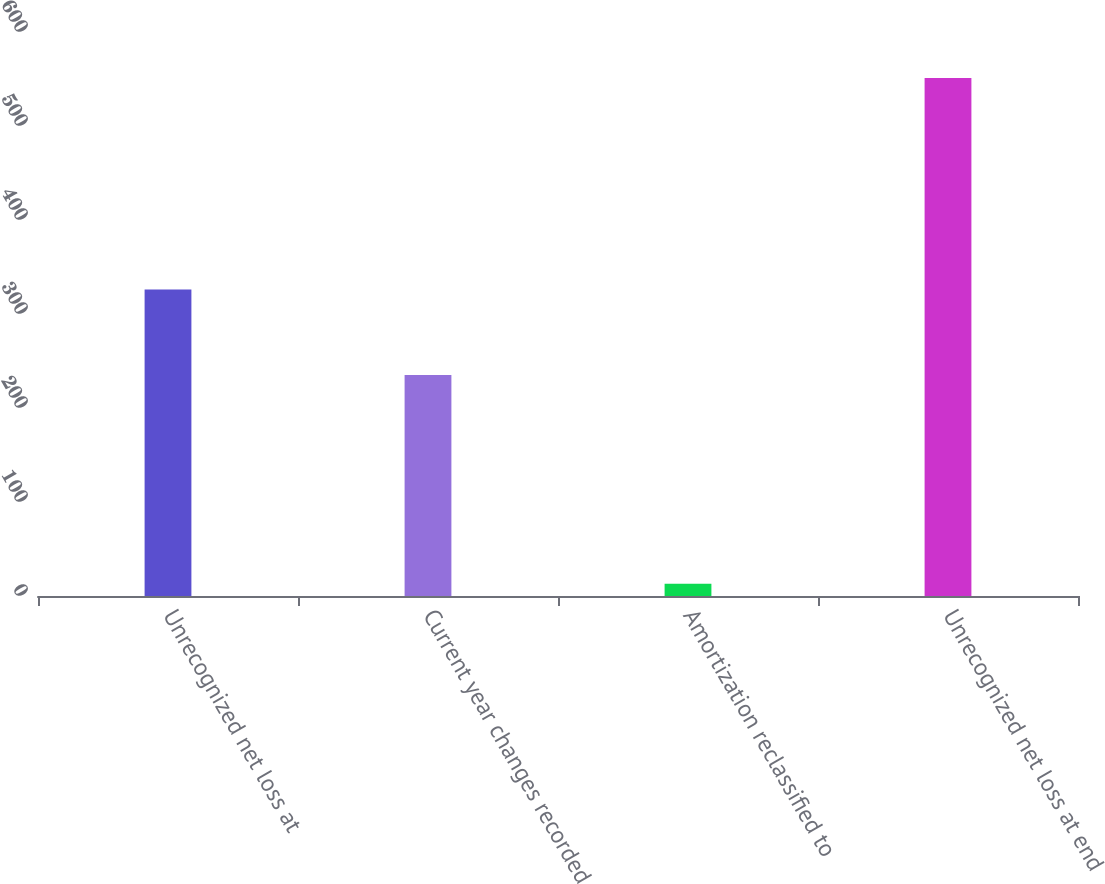<chart> <loc_0><loc_0><loc_500><loc_500><bar_chart><fcel>Unrecognized net loss at<fcel>Current year changes recorded<fcel>Amortization reclassified to<fcel>Unrecognized net loss at end<nl><fcel>326<fcel>235<fcel>13<fcel>551<nl></chart> 